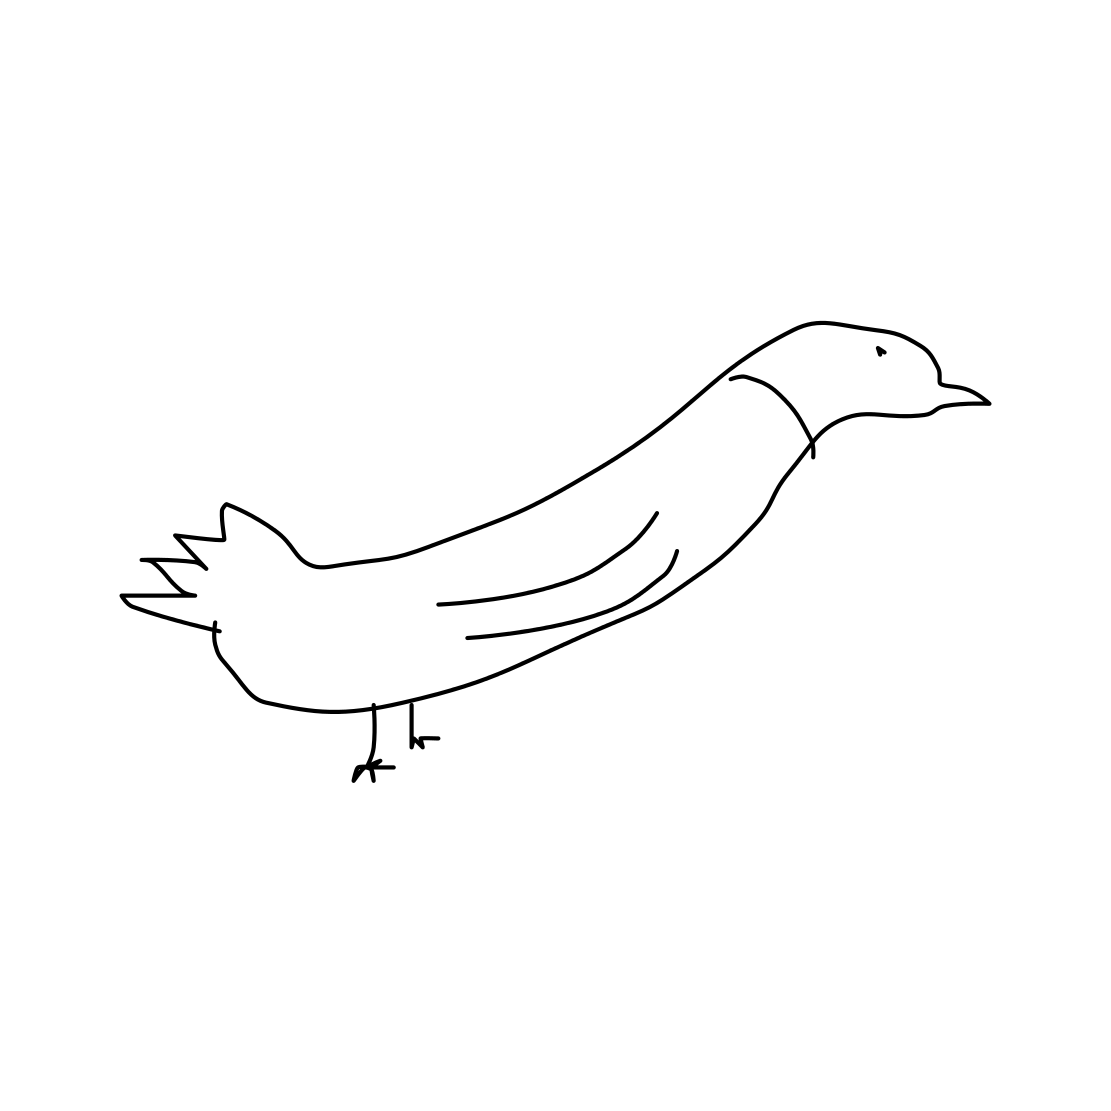Can this image be considered a good representation of the actual bird? While the image captures the essence of a bird, it is a very simplified representation. In terms of detail and proportions, it does not accurately reflect the intricacies of a bird's anatomy. 